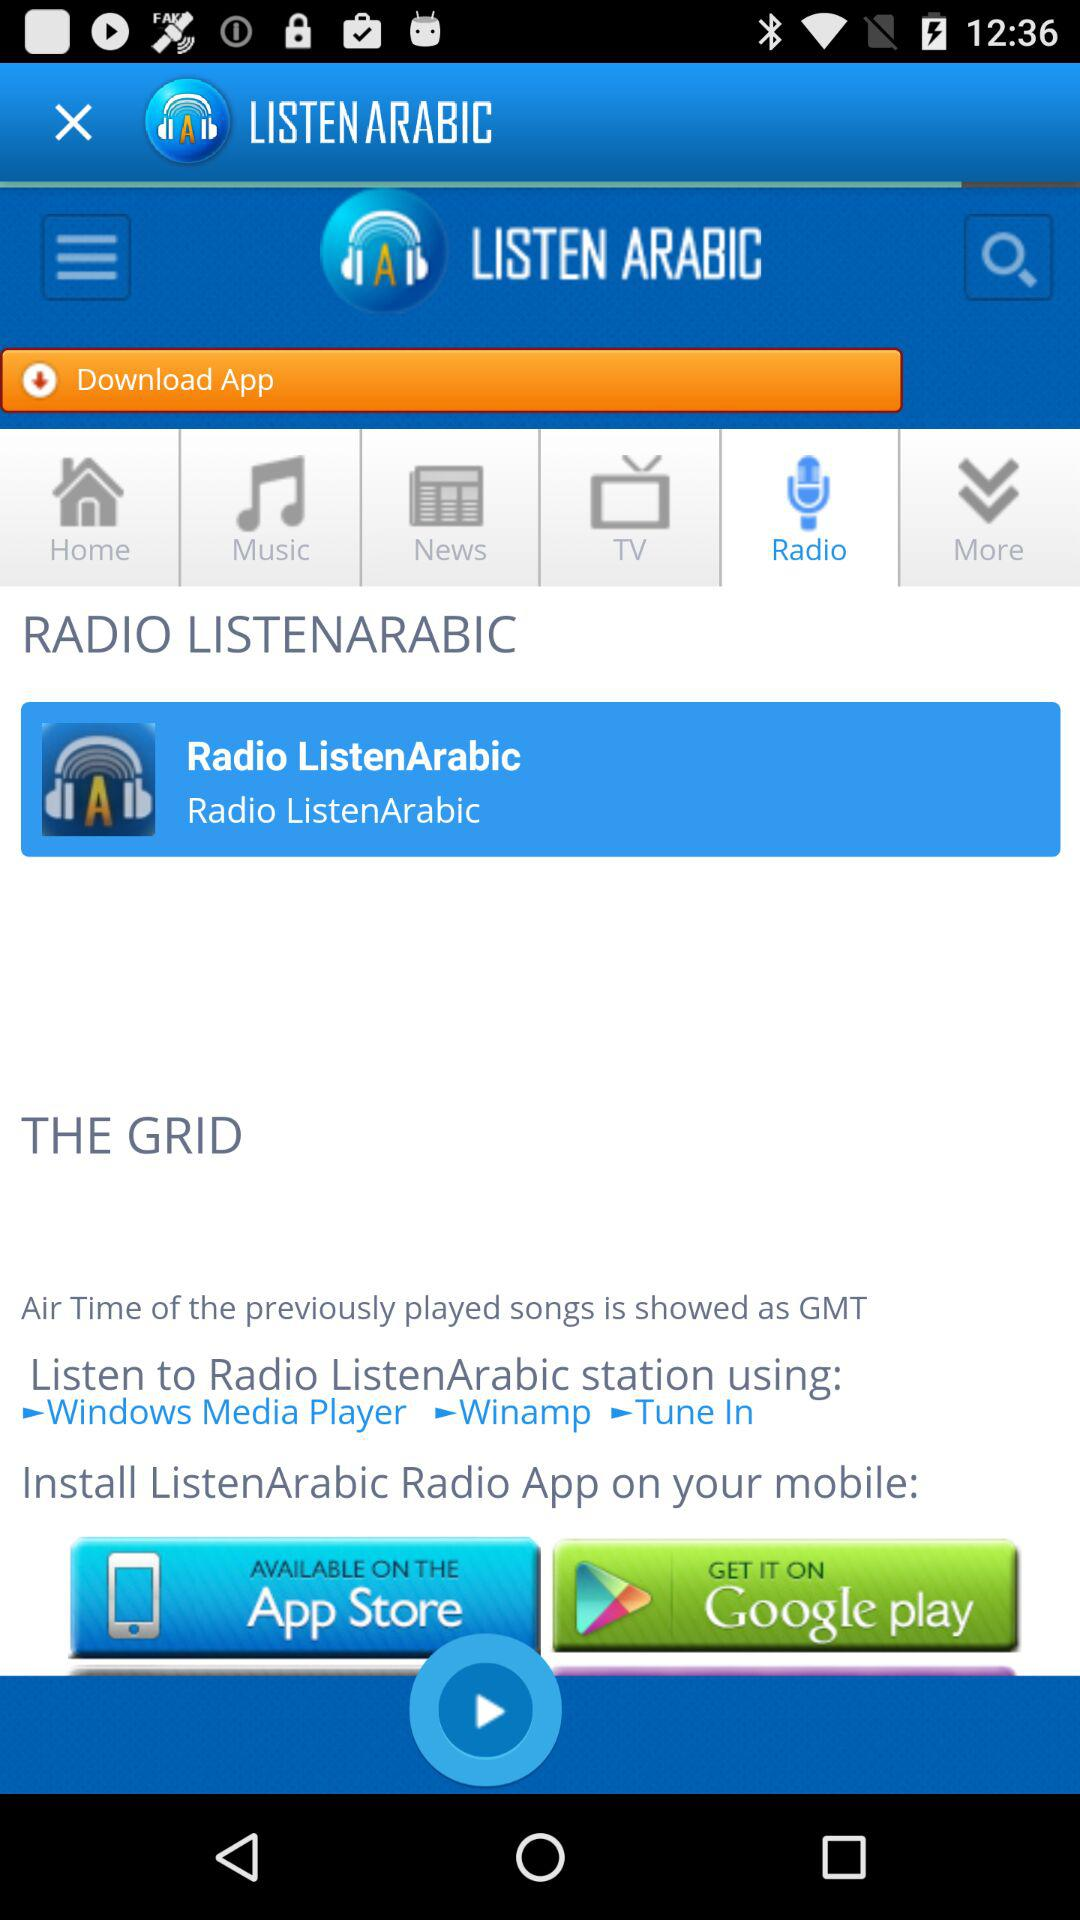What is the app name? The app name is "LISTEN ARABIC". 